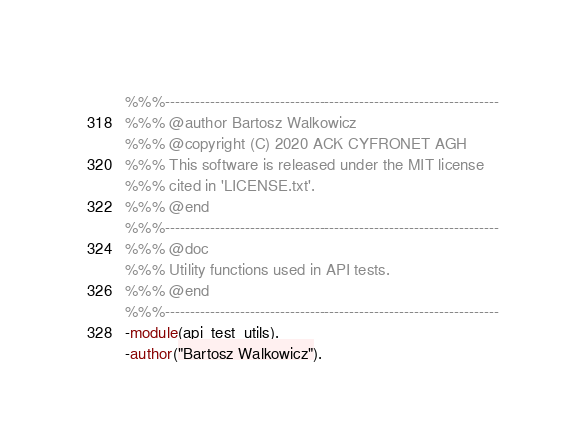Convert code to text. <code><loc_0><loc_0><loc_500><loc_500><_Erlang_>%%%-------------------------------------------------------------------
%%% @author Bartosz Walkowicz
%%% @copyright (C) 2020 ACK CYFRONET AGH
%%% This software is released under the MIT license
%%% cited in 'LICENSE.txt'.
%%% @end
%%%-------------------------------------------------------------------
%%% @doc
%%% Utility functions used in API tests.
%%% @end
%%%-------------------------------------------------------------------
-module(api_test_utils).
-author("Bartosz Walkowicz").
</code> 